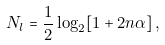<formula> <loc_0><loc_0><loc_500><loc_500>N _ { l } = \frac { 1 } { 2 } \log _ { 2 } [ 1 + 2 n \alpha ] \, ,</formula> 